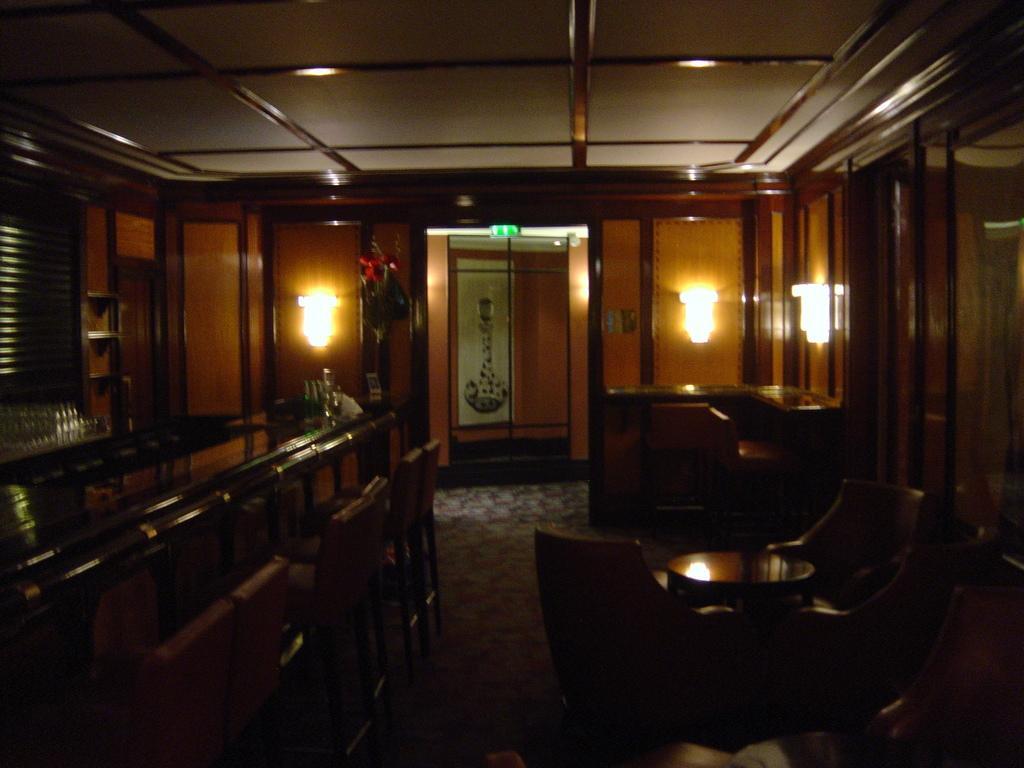Could you give a brief overview of what you see in this image? Lights are on the wall. Inside this room there are tables and chairs. 